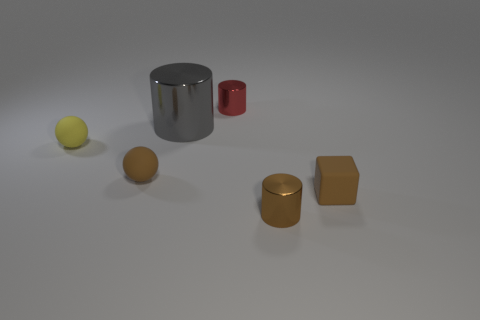Is there anything else that is the same size as the gray thing?
Your answer should be very brief. No. Are there more tiny metal objects behind the tiny brown cube than tiny gray cubes?
Ensure brevity in your answer.  Yes. How many other things are there of the same shape as the large object?
Your answer should be very brief. 2. There is a cylinder that is both behind the rubber block and right of the gray metallic cylinder; what material is it made of?
Offer a very short reply. Metal. What number of things are small metallic things or large metallic objects?
Give a very brief answer. 3. Are there more tiny yellow matte spheres than purple matte cylinders?
Offer a very short reply. Yes. There is a brown rubber object that is left of the cylinder in front of the yellow ball; what is its size?
Provide a short and direct response. Small. What color is the other small object that is the same shape as the red object?
Your answer should be compact. Brown. How big is the gray metal object?
Offer a terse response. Large. How many spheres are either gray objects or tiny things?
Offer a very short reply. 2. 